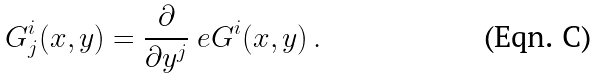Convert formula to latex. <formula><loc_0><loc_0><loc_500><loc_500>\ G ^ { i } _ { j } ( x , y ) = \frac { \partial } { \partial y ^ { j } } \ e G ^ { i } ( x , y ) \, .</formula> 